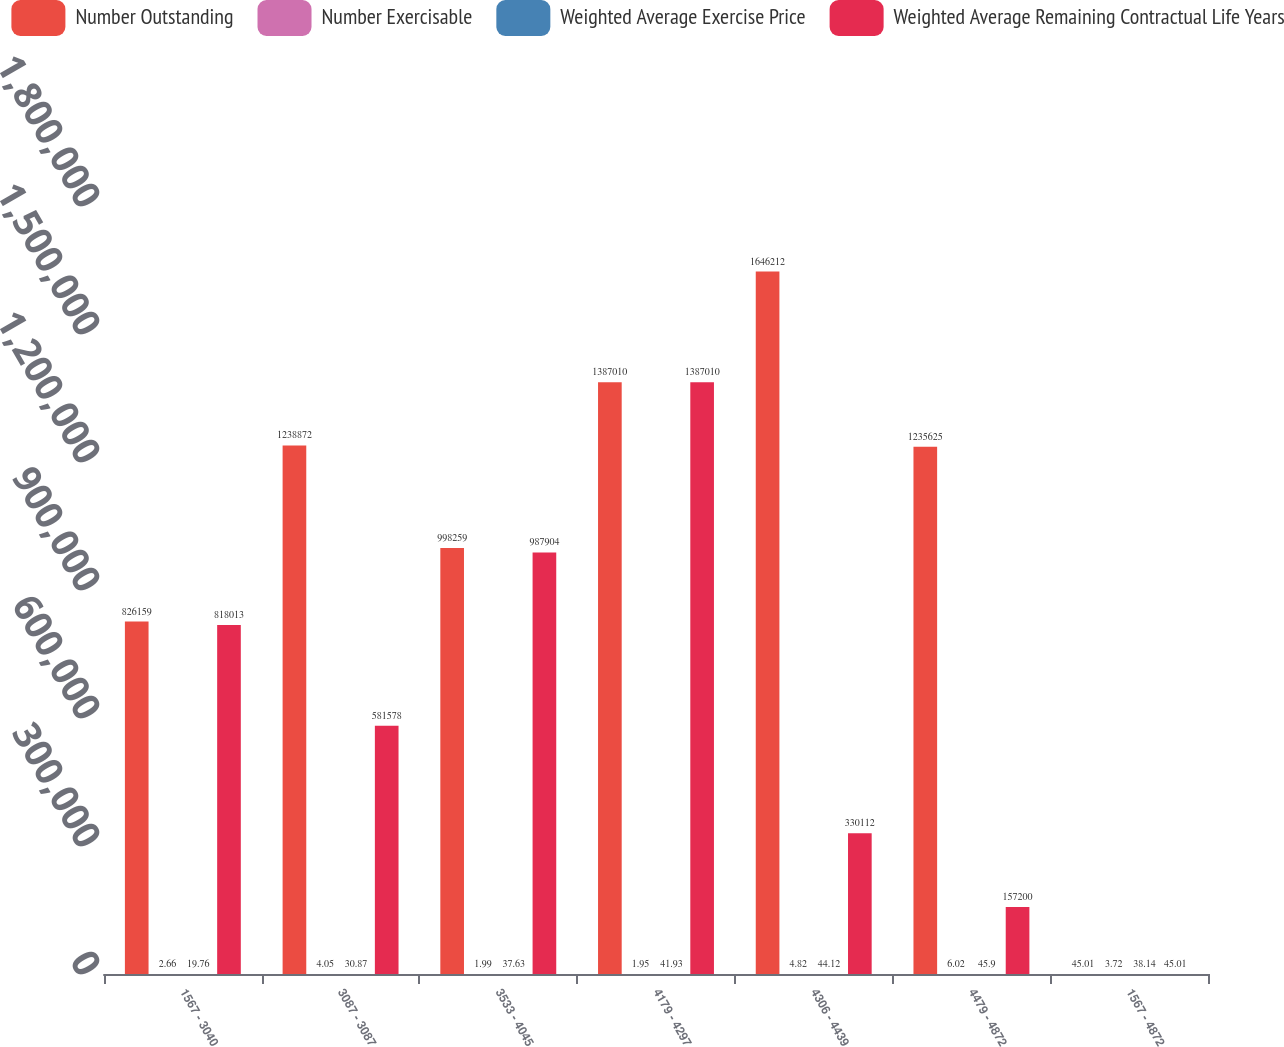<chart> <loc_0><loc_0><loc_500><loc_500><stacked_bar_chart><ecel><fcel>1567 - 3040<fcel>3087 - 3087<fcel>3533 - 4045<fcel>4179 - 4297<fcel>4306 - 4439<fcel>4479 - 4872<fcel>1567 - 4872<nl><fcel>Number Outstanding<fcel>826159<fcel>1.23887e+06<fcel>998259<fcel>1.38701e+06<fcel>1.64621e+06<fcel>1.23562e+06<fcel>45.01<nl><fcel>Number Exercisable<fcel>2.66<fcel>4.05<fcel>1.99<fcel>1.95<fcel>4.82<fcel>6.02<fcel>3.72<nl><fcel>Weighted Average Exercise Price<fcel>19.76<fcel>30.87<fcel>37.63<fcel>41.93<fcel>44.12<fcel>45.9<fcel>38.14<nl><fcel>Weighted Average Remaining Contractual Life Years<fcel>818013<fcel>581578<fcel>987904<fcel>1.38701e+06<fcel>330112<fcel>157200<fcel>45.01<nl></chart> 